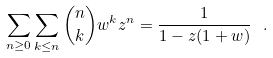<formula> <loc_0><loc_0><loc_500><loc_500>\sum _ { n \geq 0 } \sum _ { k \leq n } { n \choose k } w ^ { k } z ^ { n } = \frac { 1 } { 1 - z ( 1 + w ) } \ .</formula> 